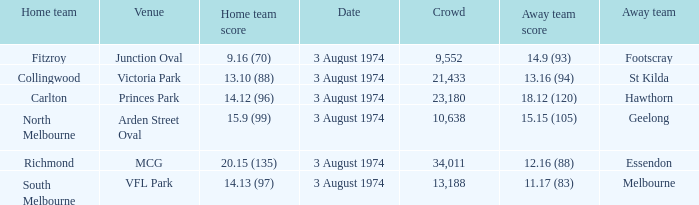Which Venue has a Home team score of 9.16 (70)? Junction Oval. 